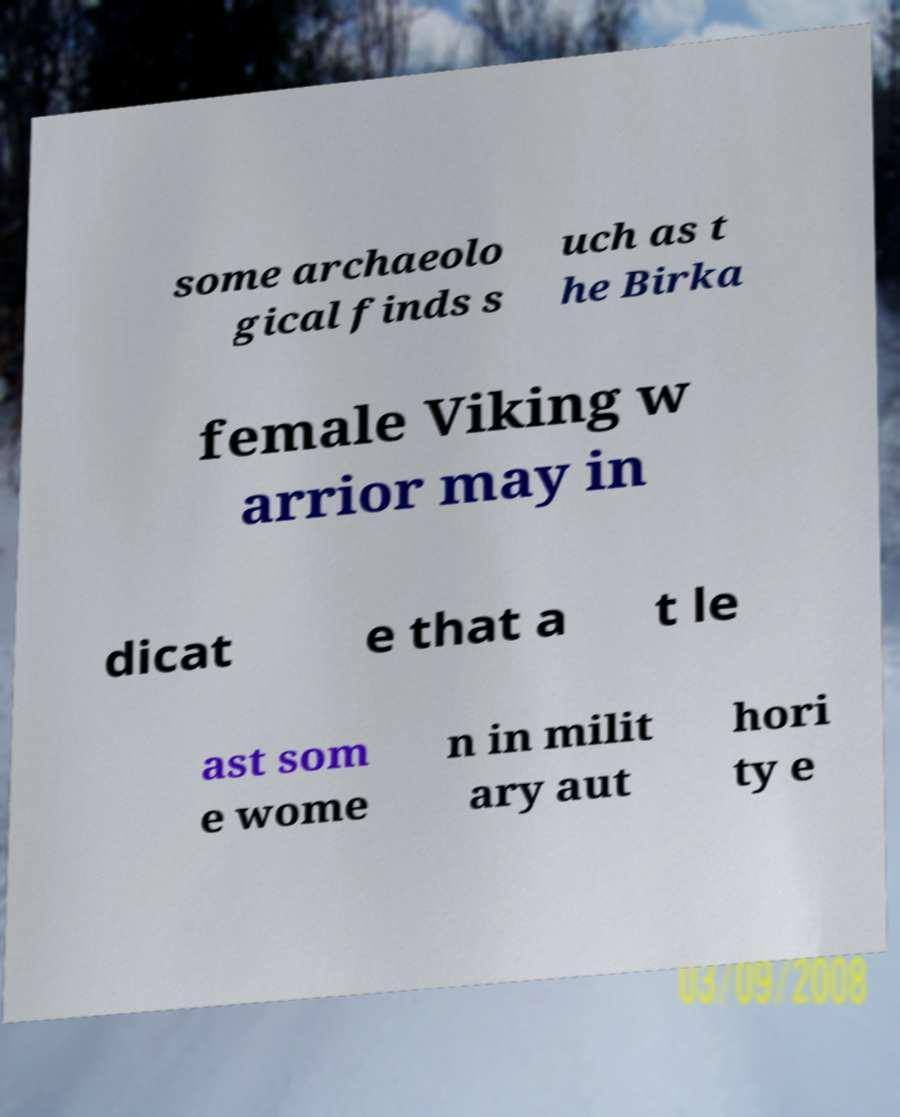There's text embedded in this image that I need extracted. Can you transcribe it verbatim? some archaeolo gical finds s uch as t he Birka female Viking w arrior may in dicat e that a t le ast som e wome n in milit ary aut hori ty e 